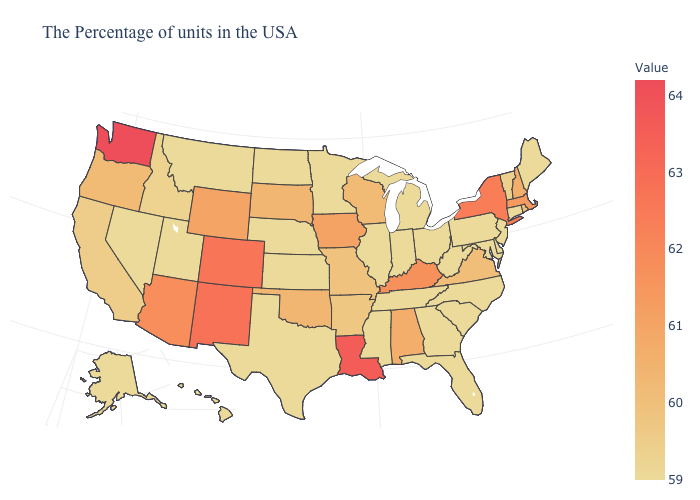Which states have the lowest value in the USA?
Quick response, please. Maine, Connecticut, New Jersey, Delaware, Maryland, Pennsylvania, North Carolina, South Carolina, West Virginia, Ohio, Florida, Georgia, Michigan, Indiana, Tennessee, Illinois, Mississippi, Minnesota, Kansas, Nebraska, Texas, North Dakota, Utah, Montana, Nevada, Alaska, Hawaii. Does Maine have the lowest value in the USA?
Quick response, please. Yes. Among the states that border New Hampshire , which have the highest value?
Concise answer only. Massachusetts. Among the states that border Minnesota , does Wisconsin have the highest value?
Write a very short answer. No. Among the states that border Arkansas , does Louisiana have the lowest value?
Give a very brief answer. No. Which states hav the highest value in the Northeast?
Short answer required. New York. 